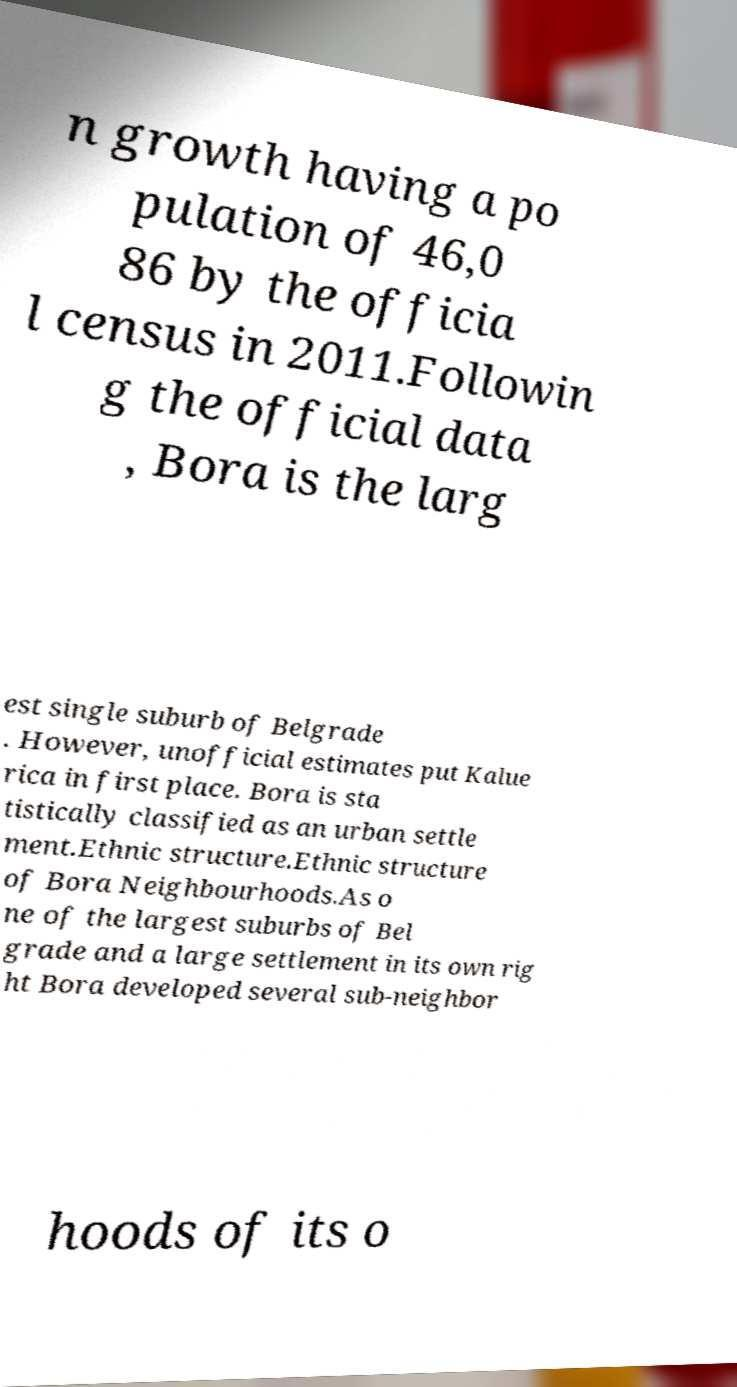Please identify and transcribe the text found in this image. n growth having a po pulation of 46,0 86 by the officia l census in 2011.Followin g the official data , Bora is the larg est single suburb of Belgrade . However, unofficial estimates put Kalue rica in first place. Bora is sta tistically classified as an urban settle ment.Ethnic structure.Ethnic structure of Bora Neighbourhoods.As o ne of the largest suburbs of Bel grade and a large settlement in its own rig ht Bora developed several sub-neighbor hoods of its o 